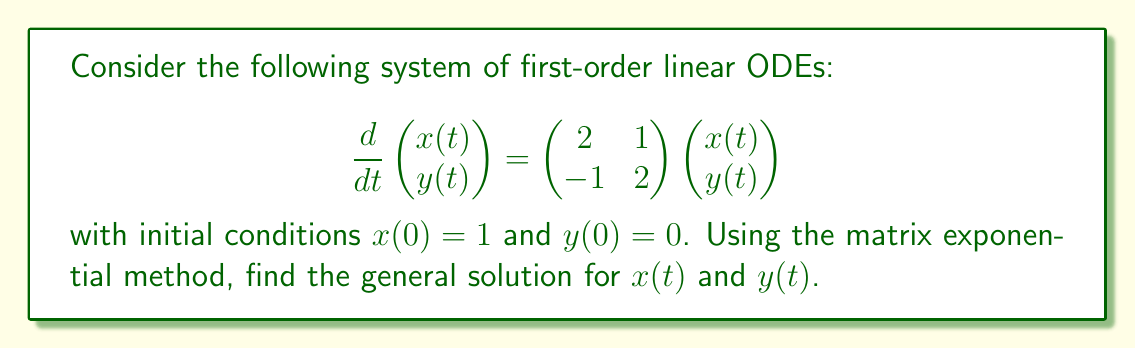Could you help me with this problem? To solve this system using matrix exponentials, we follow these steps:

1) First, we identify the coefficient matrix $A$:

   $$A = \begin{pmatrix} 2 & 1 \\ -1 & 2 \end{pmatrix}$$

2) We need to find the eigenvalues of $A$. The characteristic equation is:

   $$\det(A - \lambda I) = \begin{vmatrix} 2-\lambda & 1 \\ -1 & 2-\lambda \end{vmatrix} = (2-\lambda)^2 + 1 = \lambda^2 - 4\lambda + 5 = 0$$

3) Solving this equation, we get eigenvalues $\lambda_1 = 2 + i$ and $\lambda_2 = 2 - i$.

4) The corresponding eigenvectors are:

   For $\lambda_1 = 2 + i$: $v_1 = \begin{pmatrix} 1 \\ -i \end{pmatrix}$
   For $\lambda_2 = 2 - i$: $v_2 = \begin{pmatrix} 1 \\ i \end{pmatrix}$

5) We can now write the matrix exponential:

   $$e^{At} = e^{2t}(\cos t \cdot I + \sin t \cdot A_1)$$

   where $A_1 = \begin{pmatrix} 0 & 1 \\ -1 & 0 \end{pmatrix}$

6) The general solution is:

   $$\begin{pmatrix} x(t) \\ y(t) \end{pmatrix} = e^{At}\begin{pmatrix} x(0) \\ y(0) \end{pmatrix}$$

7) Expanding this:

   $$\begin{pmatrix} x(t) \\ y(t) \end{pmatrix} = e^{2t}\begin{pmatrix} \cos t & \sin t \\ -\sin t & \cos t \end{pmatrix}\begin{pmatrix} 1 \\ 0 \end{pmatrix}$$

8) Multiplying out the matrices:

   $$\begin{pmatrix} x(t) \\ y(t) \end{pmatrix} = e^{2t}\begin{pmatrix} \cos t \\ -\sin t \end{pmatrix}$$
Answer: The general solution is:

$$x(t) = e^{2t}\cos t$$
$$y(t) = -e^{2t}\sin t$$ 